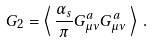<formula> <loc_0><loc_0><loc_500><loc_500>G _ { 2 } = \left \langle \, \frac { \alpha _ { s } } { \pi } G _ { \mu \nu } ^ { a } G _ { \mu \nu } ^ { a } \, \right \rangle \, .</formula> 